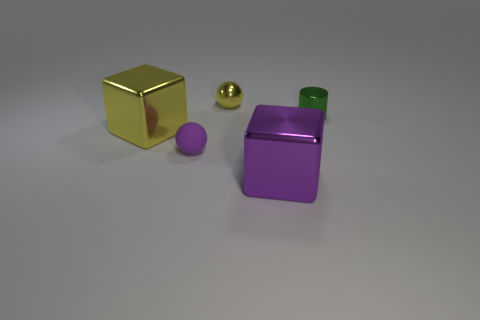Subtract all spheres. How many objects are left? 3 Add 4 yellow shiny blocks. How many objects exist? 9 Subtract all purple cubes. How many cubes are left? 1 Subtract all purple spheres. Subtract all brown cylinders. How many spheres are left? 1 Subtract all tiny yellow spheres. Subtract all purple rubber objects. How many objects are left? 3 Add 5 yellow balls. How many yellow balls are left? 6 Add 5 small green metallic objects. How many small green metallic objects exist? 6 Subtract 0 cyan spheres. How many objects are left? 5 